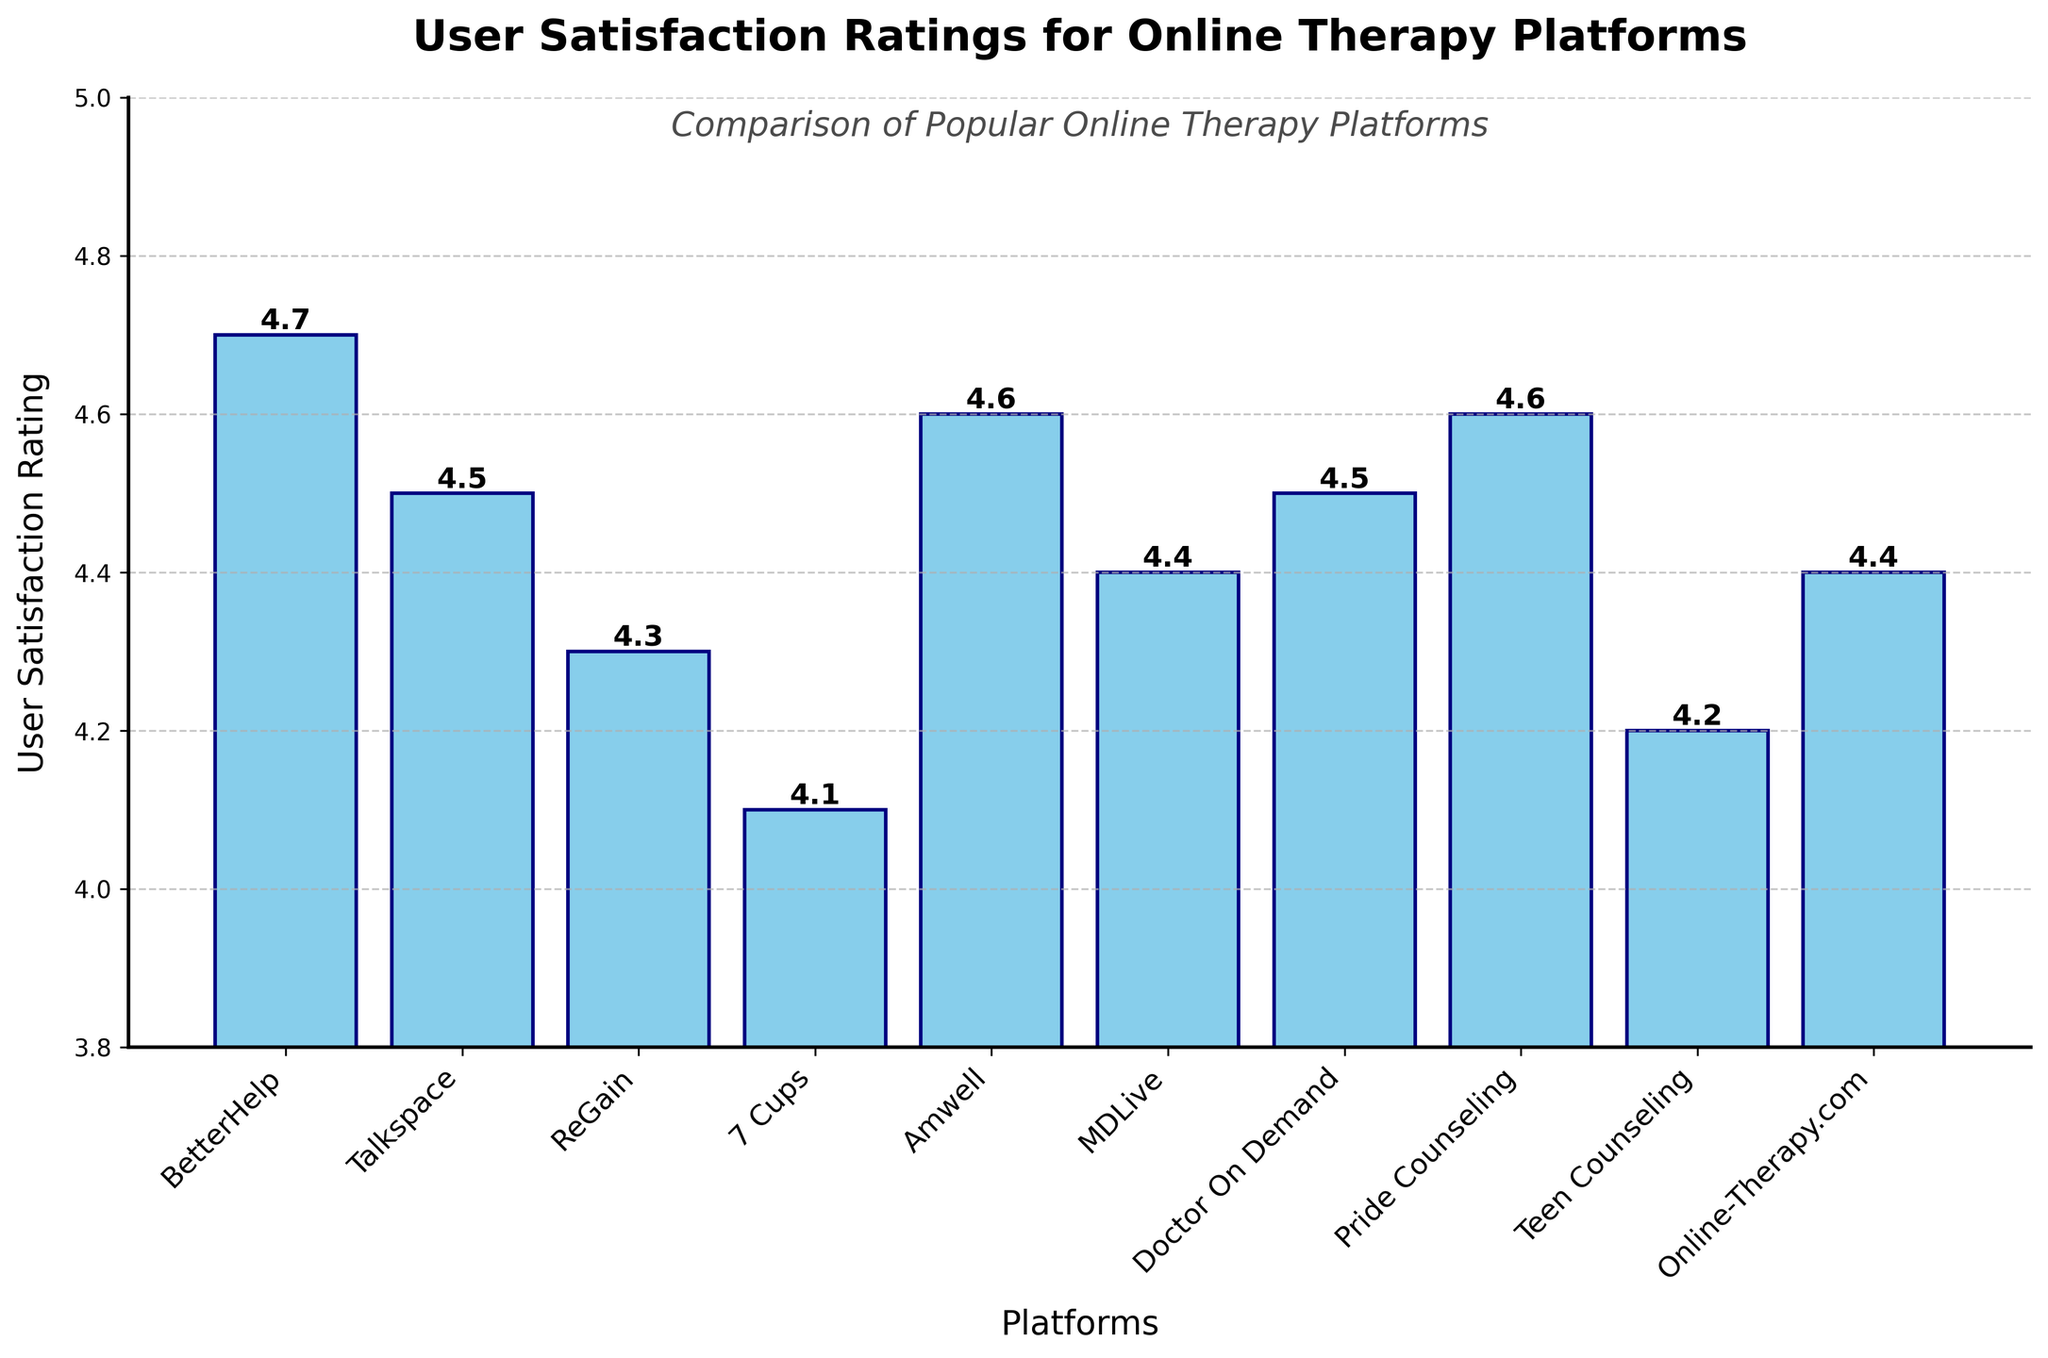What platform has the highest user satisfaction rating? By inspecting the heights of the bars in the chart, we can see which one reaches the highest point on the y-axis. The bar representing BetterHelp reaches 4.7, which is the highest rating among all platforms.
Answer: BetterHelp Which platforms have the same user satisfaction rating? To find platforms with identical ratings, we compare bars' heights. Both Talkspace and Doctor On Demand have ratings of 4.5, while Amwell and Pride Counseling each have 4.6. Additionally, MDLive and Online-Therapy.com both have 4.4.
Answer: Talkspace, Doctor On Demand; Amwell, Pride Counseling; MDLive, Online-Therapy.com What's the difference in user satisfaction rating between the highest and lowest rated platforms? We first identify the highest rating (BetterHelp at 4.7) and the lowest rating (7 Cups at 4.1). The difference is found by subtracting the smallest value from the largest value: 4.7 - 4.1.
Answer: 0.6 Which platforms have a user satisfaction rating greater than 4.5? By examining each bar's height, we identify those surpassing 4.5 on the y-axis. BetterHelp (4.7), Amwell (4.6), and Pride Counseling (4.6) all meet this condition.
Answer: BetterHelp, Amwell, Pride Counseling What is the average user satisfaction rating of all the platforms? We add all ratings together and then divide by the number of platforms. Sum of ratings: 4.7 + 4.5 + 4.3 + 4.1 + 4.6 + 4.4 + 4.5 + 4.6 + 4.2 + 4.4 = 44.3. Number of platforms = 10. Average: 44.3 / 10.
Answer: 4.43 Which platform has the second highest user satisfaction rating? First, identify the highest rating platform (BetterHelp at 4.7). Next, find the second highest bar, which corresponds to Amwell and Pride Counseling, both with a rating of 4.6.
Answer: Amwell, Pride Counseling What's the combined user satisfaction rating for platforms rated below 4.5? Identify platforms with ratings below 4.5: ReGain (4.3), 7 Cups (4.1), Teen Counseling (4.2). Add these ratings together: 4.3 + 4.1 + 4.2.
Answer: 12.6 Is there a significant visual difference in heights among the bars? By scanning the chart, one can observe that although the differences in user satisfaction ratings are relatively small (ranging from 4.1 to 4.7), these small numerical differences translate into noticeable differences in bar heights.
Answer: Yes How many platforms have a user satisfaction rating of 4.4? Count the platforms whose bars align with the 4.4 mark on the y-axis. Both MDLive and Online-Therapy.com have this rating.
Answer: Two 